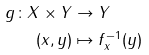Convert formula to latex. <formula><loc_0><loc_0><loc_500><loc_500>g \colon X \times Y & \to Y \\ ( x , y ) & \mapsto f _ { x } ^ { - 1 } ( y )</formula> 